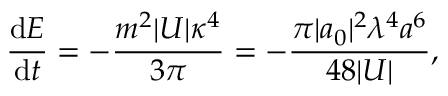<formula> <loc_0><loc_0><loc_500><loc_500>\frac { d E } { d t } = - \frac { m ^ { 2 } | U | \kappa ^ { 4 } } { 3 \pi } = - \frac { \pi | a _ { 0 } | ^ { 2 } \lambda ^ { 4 } a ^ { 6 } } { 4 8 | U | } ,</formula> 